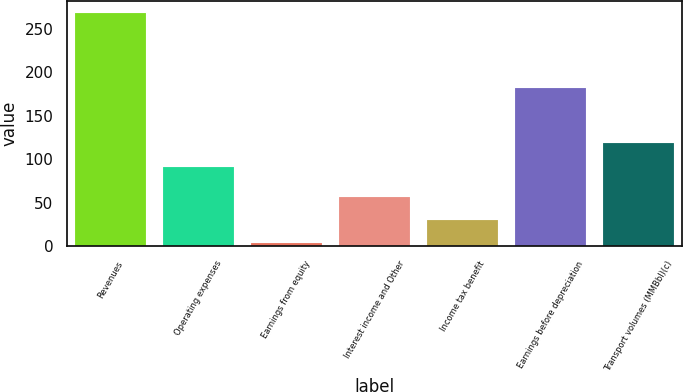<chart> <loc_0><loc_0><loc_500><loc_500><bar_chart><fcel>Revenues<fcel>Operating expenses<fcel>Earnings from equity<fcel>Interest income and Other<fcel>Income tax benefit<fcel>Earnings before depreciation<fcel>Transport volumes (MMBbl)(c)<nl><fcel>268.5<fcel>91.6<fcel>3.3<fcel>56.34<fcel>29.82<fcel>181.6<fcel>118.12<nl></chart> 